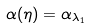Convert formula to latex. <formula><loc_0><loc_0><loc_500><loc_500>\alpha ( \eta ) = \alpha _ { \lambda _ { 1 } }</formula> 